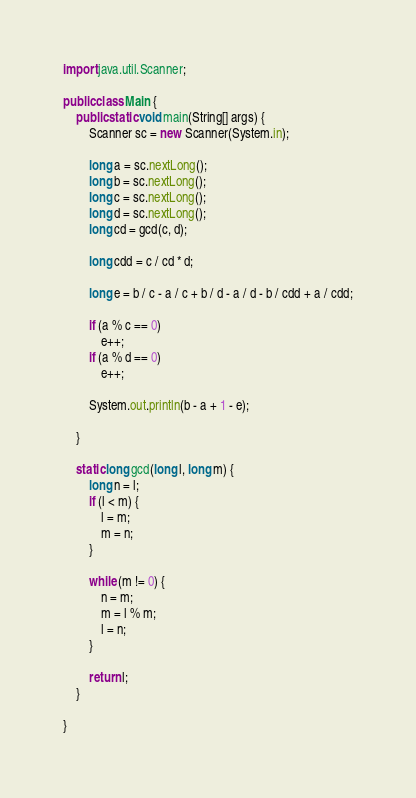Convert code to text. <code><loc_0><loc_0><loc_500><loc_500><_Java_>

import java.util.Scanner;

public class Main {
	public static void main(String[] args) {
		Scanner sc = new Scanner(System.in);

		long a = sc.nextLong();
		long b = sc.nextLong();
		long c = sc.nextLong();
		long d = sc.nextLong();
		long cd = gcd(c, d);

		long cdd = c / cd * d;

		long e = b / c - a / c + b / d - a / d - b / cdd + a / cdd;

		if (a % c == 0)
			e++;
		if (a % d == 0)
			e++;

		System.out.println(b - a + 1 - e);

	}

	static long gcd(long l, long m) {
		long n = l;
		if (l < m) {
			l = m;
			m = n;
		}

		while (m != 0) {
			n = m;
			m = l % m;
			l = n;
		}

		return l;
	}

}
</code> 